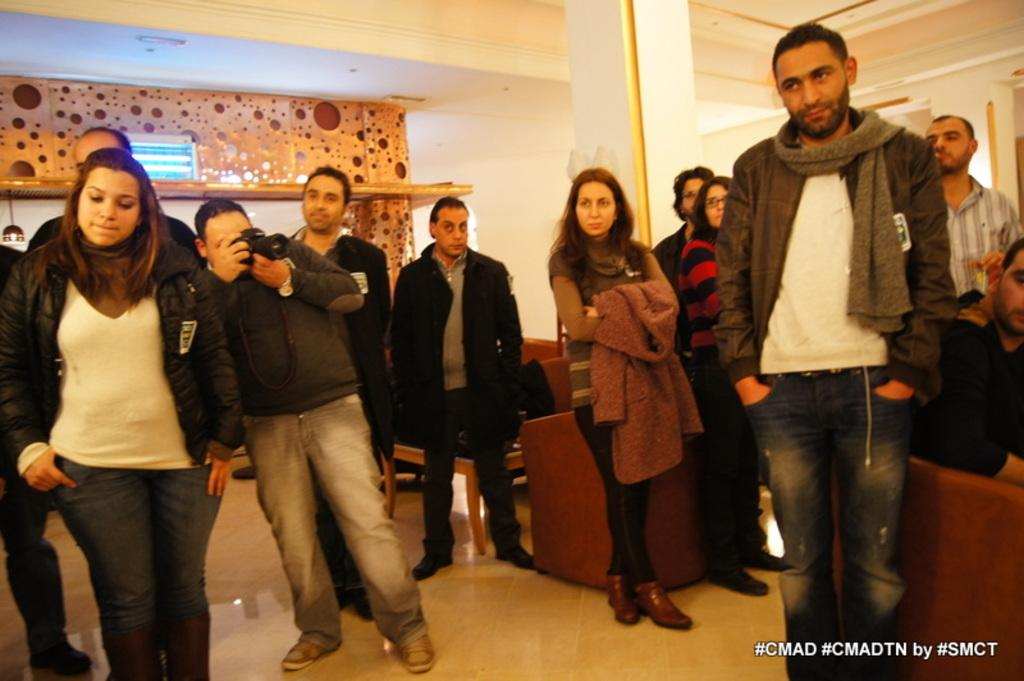<image>
Relay a brief, clear account of the picture shown. A group of men and women are gathered in a room with a hashtag of CMAD 